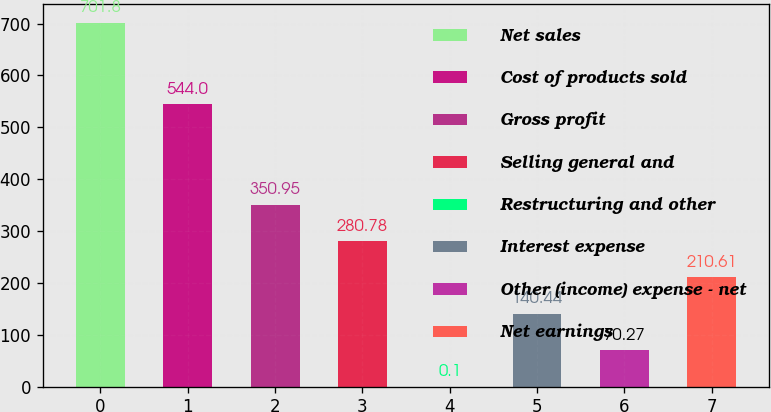<chart> <loc_0><loc_0><loc_500><loc_500><bar_chart><fcel>Net sales<fcel>Cost of products sold<fcel>Gross profit<fcel>Selling general and<fcel>Restructuring and other<fcel>Interest expense<fcel>Other (income) expense - net<fcel>Net earnings<nl><fcel>701.8<fcel>544<fcel>350.95<fcel>280.78<fcel>0.1<fcel>140.44<fcel>70.27<fcel>210.61<nl></chart> 